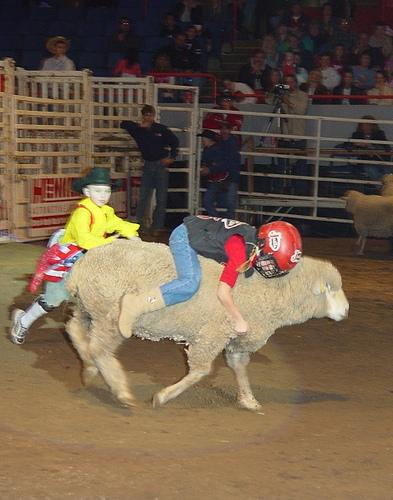Why are the little people riding the sheep?

Choices:
A) are children
B) no horses
C) forced to
D) going home are children 